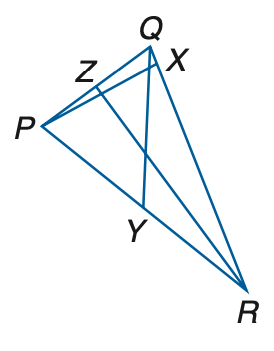Answer the mathemtical geometry problem and directly provide the correct option letter.
Question: In \triangle P Q R, Z Q = 3 a - 11, Z P = a + 5, P Y = 2 c - 1, Y R = 4 c - 11, m \angle P R Z = 4 b - 17, m \angle Z R Q = 3 b - 4, m \angle Q Y R = 7 b + 6, and m \angle P X R = 2 a + 10. P X is an altitude of \triangle P Q R. Find a.
Choices: A: 10 B: 20 C: 30 D: 40 D 